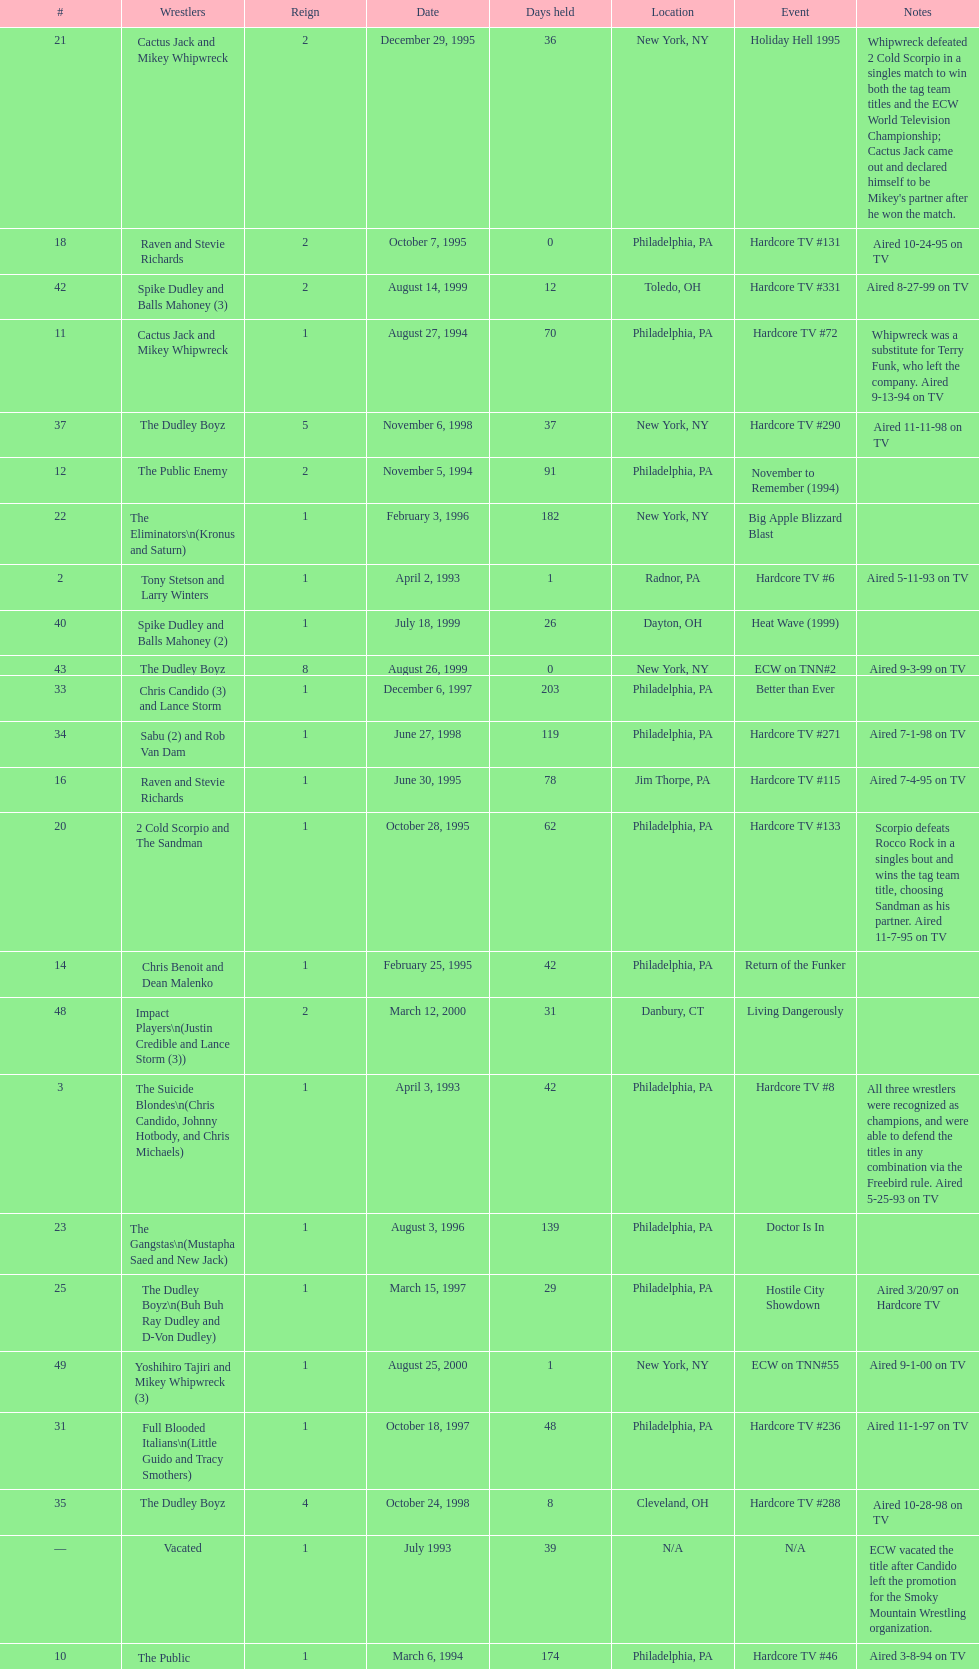How many days did hardcore tv #6 take? 1. 